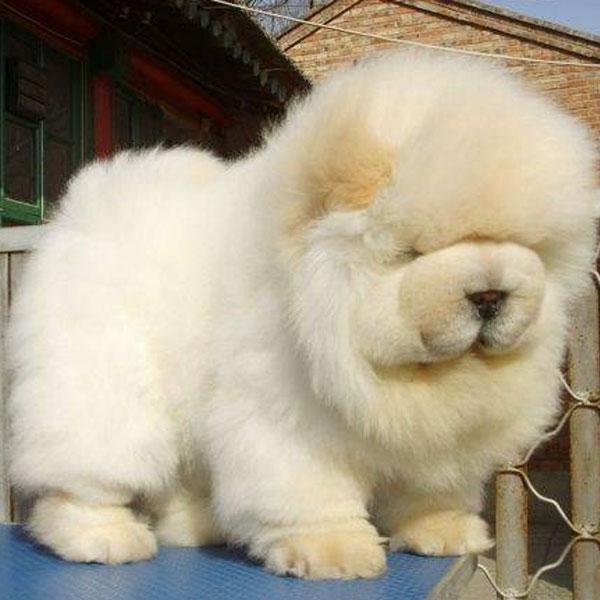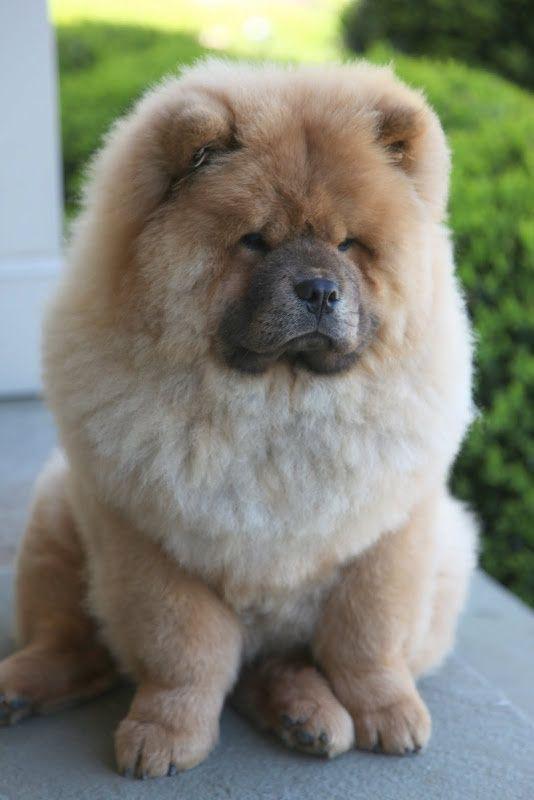The first image is the image on the left, the second image is the image on the right. Given the left and right images, does the statement "An image shows two chow puppies side by side between stone walls." hold true? Answer yes or no. No. The first image is the image on the left, the second image is the image on the right. Examine the images to the left and right. Is the description "THere are exactly two dogs in the image on the left." accurate? Answer yes or no. No. 